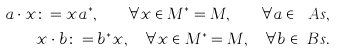Convert formula to latex. <formula><loc_0><loc_0><loc_500><loc_500>a \cdot x \colon = x a ^ { * } , \quad \forall x \in M ^ { * } = M , \quad \forall a \in \ A s , \\ x \cdot b \colon = b ^ { * } x , \quad \forall x \in M ^ { * } = M , \quad \forall b \in \ B s .</formula> 